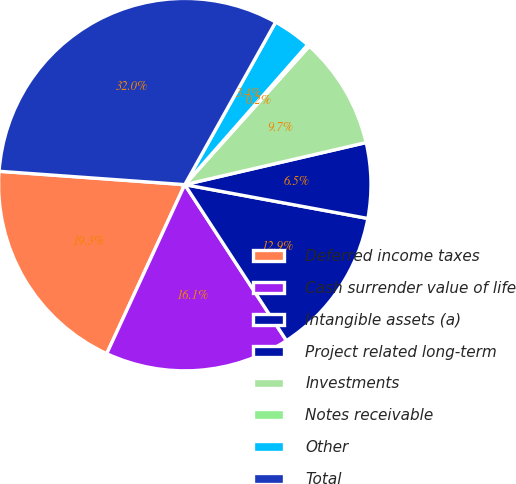<chart> <loc_0><loc_0><loc_500><loc_500><pie_chart><fcel>Deferred income taxes<fcel>Cash surrender value of life<fcel>Intangible assets (a)<fcel>Project related long-term<fcel>Investments<fcel>Notes receivable<fcel>Other<fcel>Total<nl><fcel>19.26%<fcel>16.08%<fcel>12.9%<fcel>6.54%<fcel>9.72%<fcel>0.18%<fcel>3.36%<fcel>31.97%<nl></chart> 